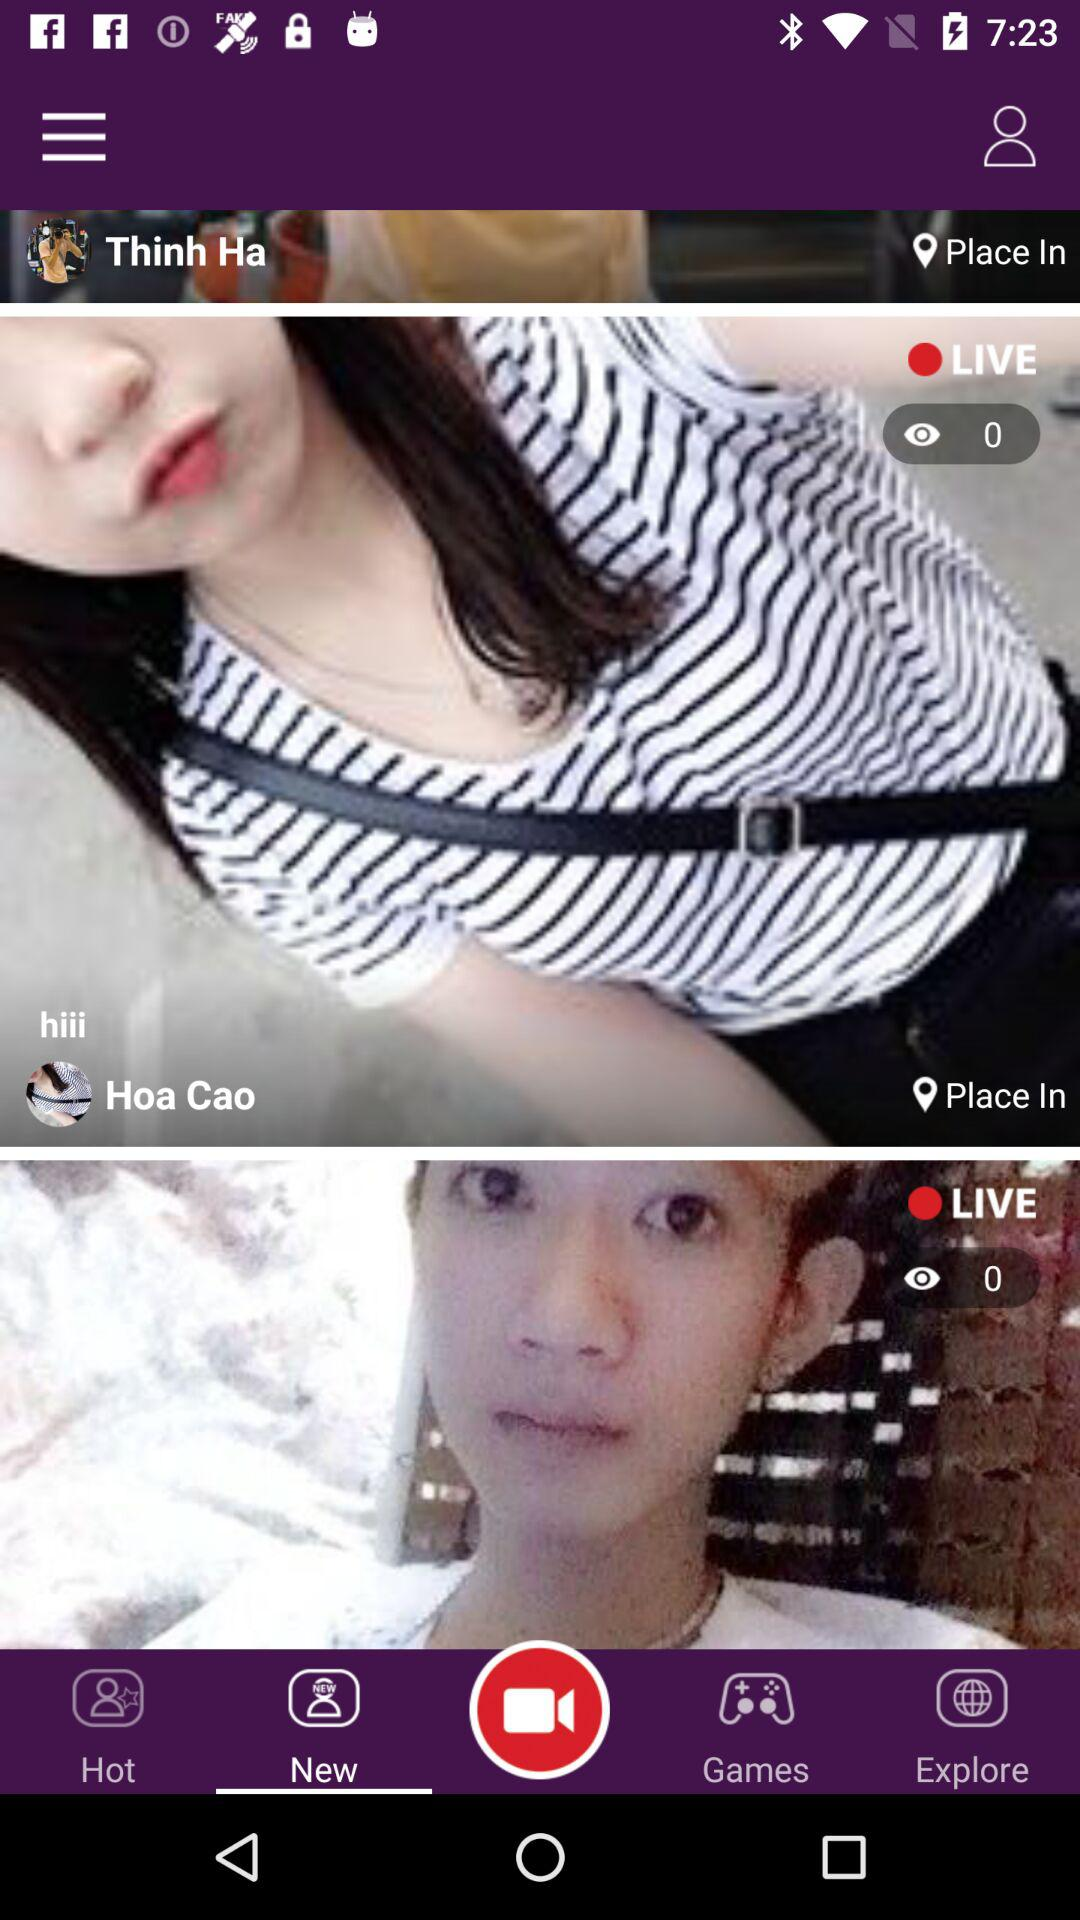How many views are there for Hoa Cao? There are zero views for Hoa Cao. 